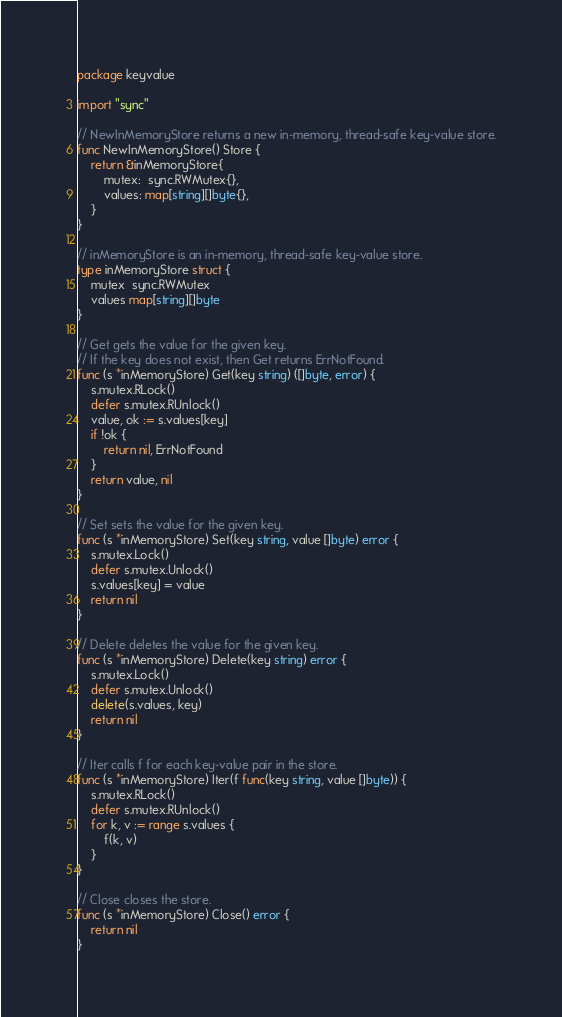Convert code to text. <code><loc_0><loc_0><loc_500><loc_500><_Go_>package keyvalue

import "sync"

// NewInMemoryStore returns a new in-memory, thread-safe key-value store.
func NewInMemoryStore() Store {
	return &inMemoryStore{
		mutex:  sync.RWMutex{},
		values: map[string][]byte{},
	}
}

// inMemoryStore is an in-memory, thread-safe key-value store.
type inMemoryStore struct {
	mutex  sync.RWMutex
	values map[string][]byte
}

// Get gets the value for the given key.
// If the key does not exist, then Get returns ErrNotFound.
func (s *inMemoryStore) Get(key string) ([]byte, error) {
	s.mutex.RLock()
	defer s.mutex.RUnlock()
	value, ok := s.values[key]
	if !ok {
		return nil, ErrNotFound
	}
	return value, nil
}

// Set sets the value for the given key.
func (s *inMemoryStore) Set(key string, value []byte) error {
	s.mutex.Lock()
	defer s.mutex.Unlock()
	s.values[key] = value
	return nil
}

// Delete deletes the value for the given key.
func (s *inMemoryStore) Delete(key string) error {
	s.mutex.Lock()
	defer s.mutex.Unlock()
	delete(s.values, key)
	return nil
}

// Iter calls f for each key-value pair in the store.
func (s *inMemoryStore) Iter(f func(key string, value []byte)) {
	s.mutex.RLock()
	defer s.mutex.RUnlock()
	for k, v := range s.values {
		f(k, v)
	}
}

// Close closes the store.
func (s *inMemoryStore) Close() error {
	return nil
}
</code> 